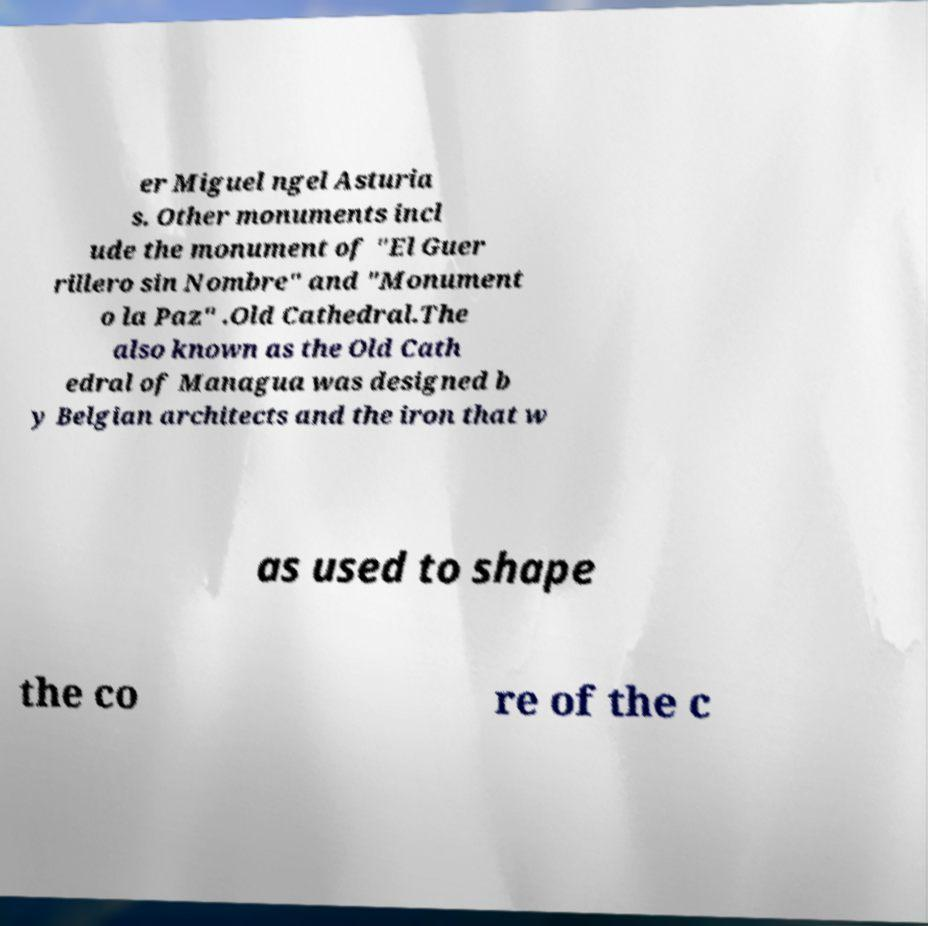Please read and relay the text visible in this image. What does it say? er Miguel ngel Asturia s. Other monuments incl ude the monument of "El Guer rillero sin Nombre" and "Monument o la Paz" .Old Cathedral.The also known as the Old Cath edral of Managua was designed b y Belgian architects and the iron that w as used to shape the co re of the c 